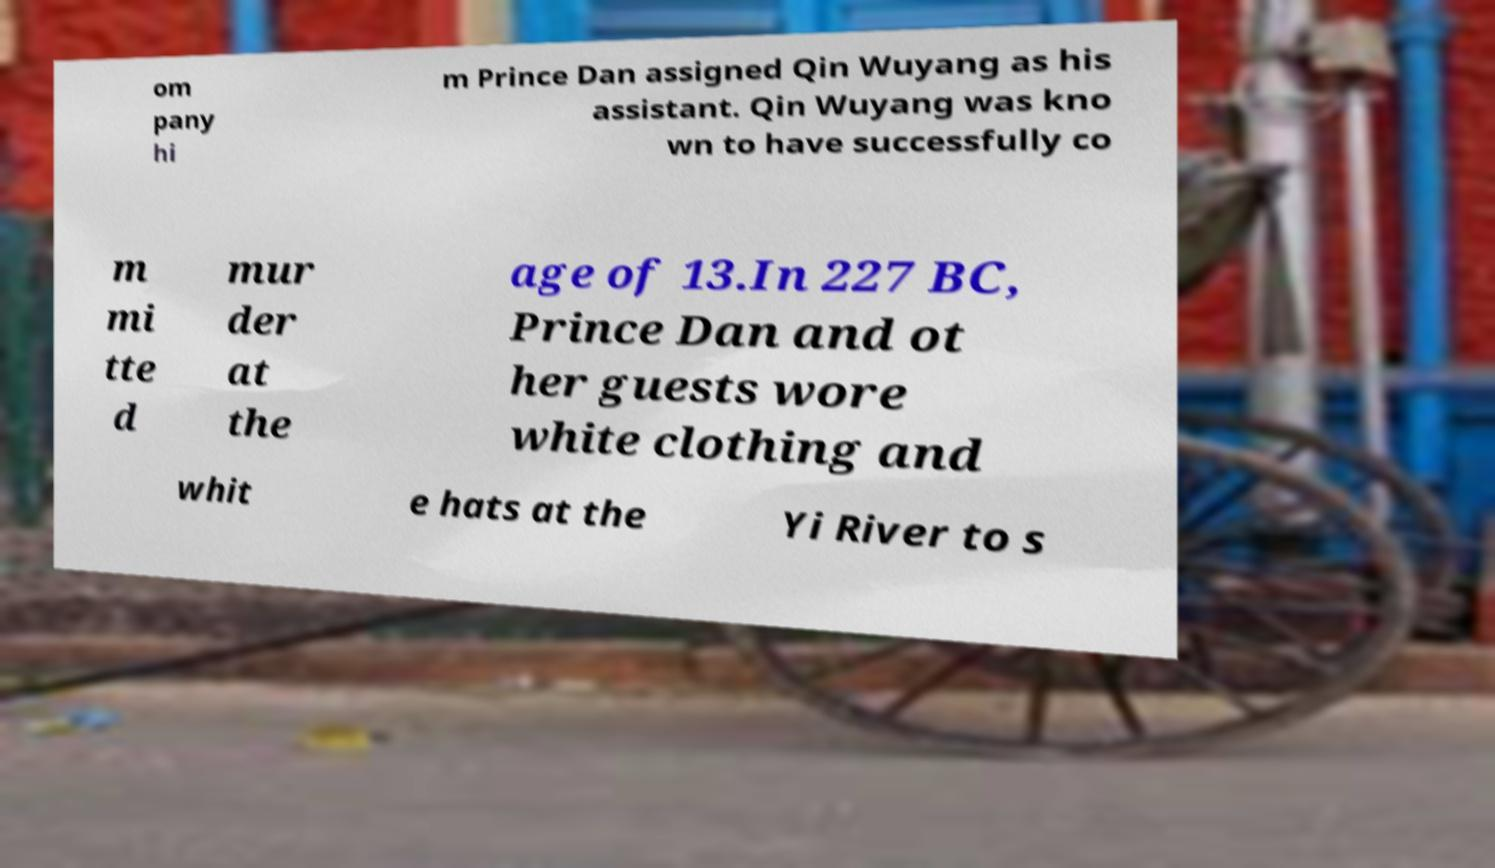There's text embedded in this image that I need extracted. Can you transcribe it verbatim? om pany hi m Prince Dan assigned Qin Wuyang as his assistant. Qin Wuyang was kno wn to have successfully co m mi tte d mur der at the age of 13.In 227 BC, Prince Dan and ot her guests wore white clothing and whit e hats at the Yi River to s 